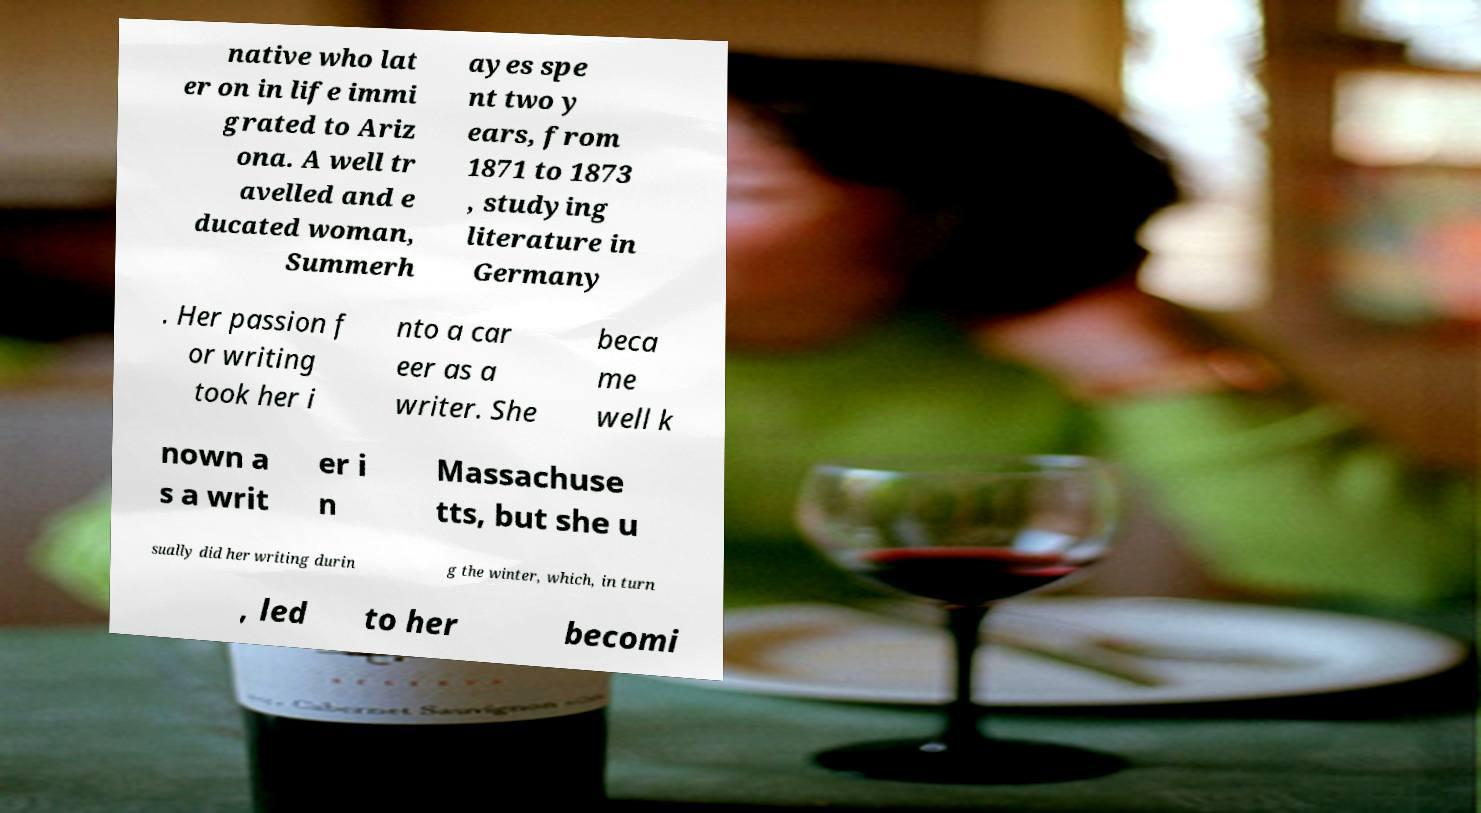For documentation purposes, I need the text within this image transcribed. Could you provide that? native who lat er on in life immi grated to Ariz ona. A well tr avelled and e ducated woman, Summerh ayes spe nt two y ears, from 1871 to 1873 , studying literature in Germany . Her passion f or writing took her i nto a car eer as a writer. She beca me well k nown a s a writ er i n Massachuse tts, but she u sually did her writing durin g the winter, which, in turn , led to her becomi 